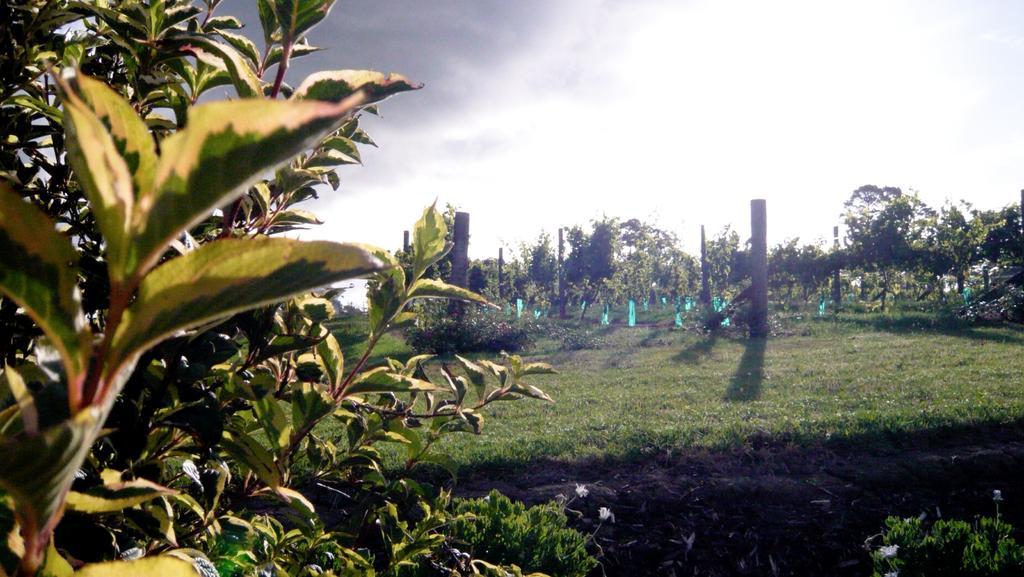In one or two sentences, can you explain what this image depicts? In this image I can see the white color flowers to the plants. In the background I can see many trees, poles, clouds and the sky. 